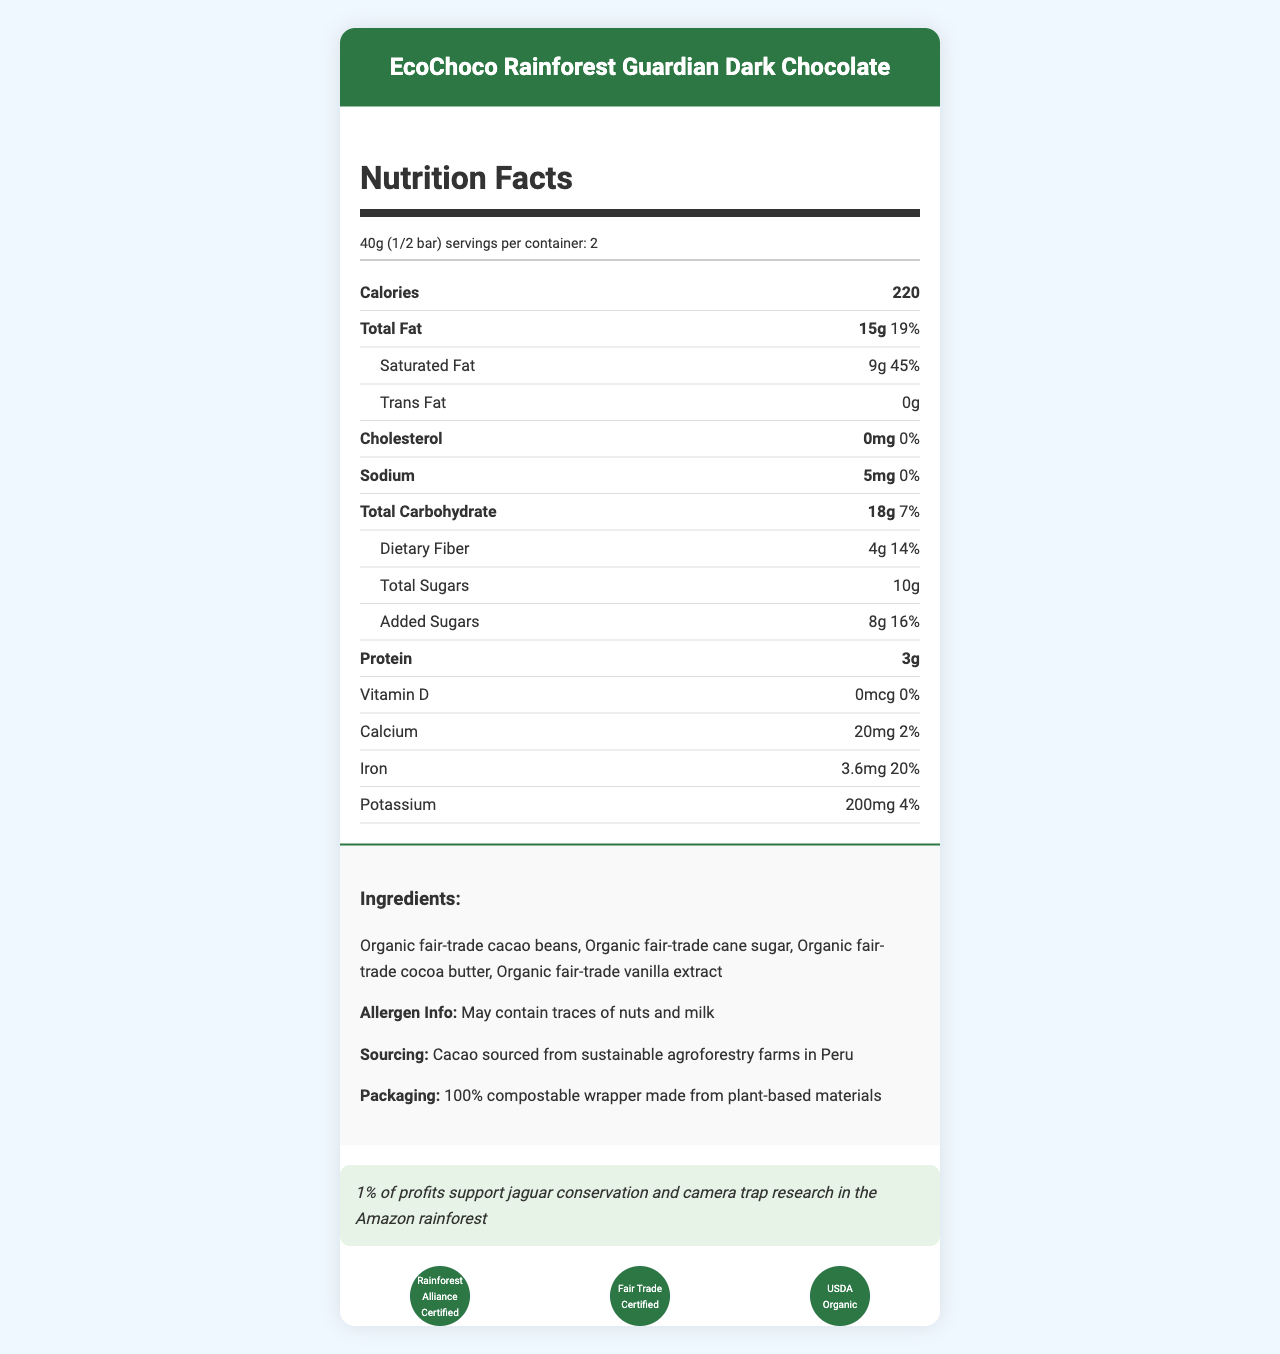what is the serving size? The serving size is explicitly listed as 40g (1/2 bar) in the document.
Answer: 40g (1/2 bar) how many servings are there per container? The document mentions that there are 2 servings per container.
Answer: 2 how many calories are in one serving? The document states that each serving contains 220 calories.
Answer: 220 how much saturated fat does one serving contain? The saturated fat content per serving is listed as 9g in the document.
Answer: 9g what is the percentage of daily value for iron in one serving? The daily value percentage for iron in one serving is given as 20%.
Answer: 20% how much trans fat does the chocolate contain? A. 0g B. 1g C. 2g The document states that the trans fat content is 0g.
Answer: A what is the amount of added sugars per serving? A. 4g B. 8g C. 10g D. 12g The document lists the added sugars per serving as 8g.
Answer: B is this chocolate bar suitable for someone with a nut allergy? The allergen information indicates that the bar may contain traces of nuts.
Answer: No is there any Vitamin D in this chocolate? The document shows that Vitamin D content is 0 mcg.
Answer: No what is the main conservation message of the document? The conservation message is explicitly stated as supporting jaguar conservation and camera trap research in the Amazon rainforest.
Answer: 1% of profits support jaguar conservation and camera trap research in the Amazon rainforest describe the main idea of the document. The document includes nutrition facts, ingredients, allergen information, sourcing details, packaging material, conservation message, and certifications.
Answer: The document provides detailed nutritional information about the EcoChoco Rainforest Guardian Dark Chocolate bar, its ingredients, sourcing, packaging, and certifications. It emphasizes the product's contributions to conservation efforts, indicating that 1% of profits support jaguar conservation and camera trap research in the Amazon rainforest. how much calcium does one serving provide? The document lists the calcium content per serving as 20 mg.
Answer: 20 mg what type of packaging is used for this chocolate bar? The document states that the packaging is made from 100% compostable plant-based materials.
Answer: 100% compostable wrapper made from plant-based materials what is the source of the cacao used in this chocolate bar? The document mentions that the cacao is sourced from sustainable agroforestry farms in Peru.
Answer: Sustainable agroforestry farms in Peru does this chocolate bar contain milk? The allergen information mentions that the bar may contain traces of milk, but it does not confirm whether it is an ingredient or just a possible contaminant.
Answer: Not enough information what are the main ingredients in this chocolate bar? The ingredients list specifies these four main ingredients.
Answer: Organic fair-trade cacao beans, organic fair-trade cane sugar, organic fair-trade cocoa butter, organic fair-trade vanilla extract 